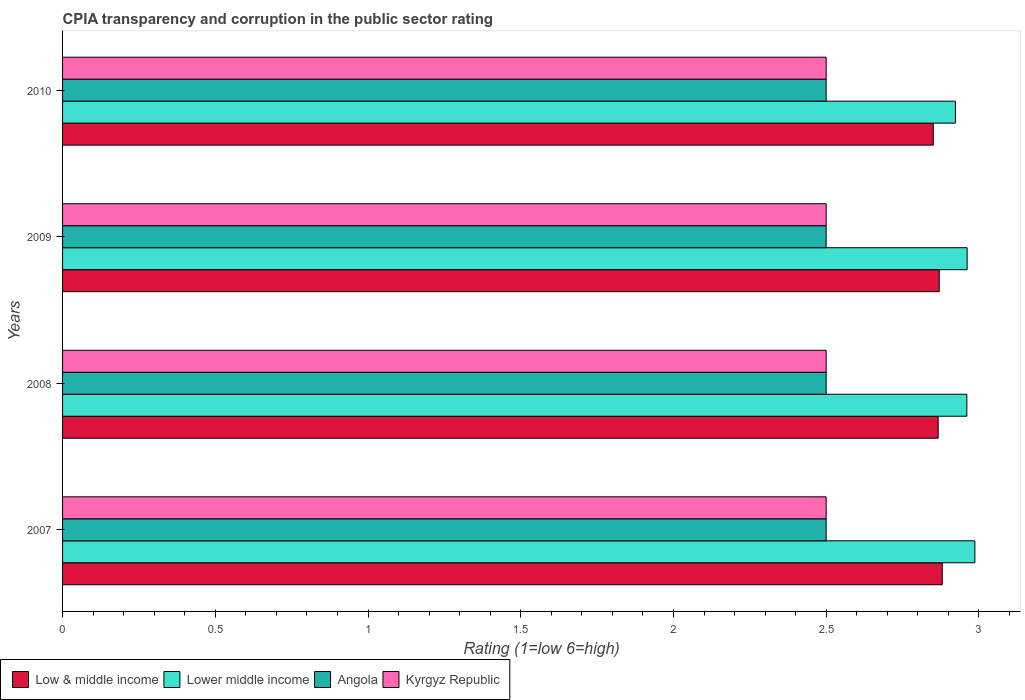Are the number of bars per tick equal to the number of legend labels?
Offer a very short reply. Yes. How many bars are there on the 4th tick from the top?
Your response must be concise. 4. How many bars are there on the 3rd tick from the bottom?
Ensure brevity in your answer.  4. What is the label of the 4th group of bars from the top?
Provide a short and direct response. 2007. In how many cases, is the number of bars for a given year not equal to the number of legend labels?
Provide a short and direct response. 0. What is the CPIA rating in Lower middle income in 2008?
Keep it short and to the point. 2.96. Across all years, what is the maximum CPIA rating in Low & middle income?
Give a very brief answer. 2.88. Across all years, what is the minimum CPIA rating in Lower middle income?
Your answer should be very brief. 2.92. In which year was the CPIA rating in Kyrgyz Republic maximum?
Your answer should be compact. 2007. What is the total CPIA rating in Lower middle income in the graph?
Keep it short and to the point. 11.83. What is the difference between the CPIA rating in Low & middle income in 2008 and that in 2010?
Provide a succinct answer. 0.02. What is the difference between the CPIA rating in Kyrgyz Republic in 2010 and the CPIA rating in Low & middle income in 2009?
Provide a succinct answer. -0.37. In the year 2009, what is the difference between the CPIA rating in Lower middle income and CPIA rating in Kyrgyz Republic?
Provide a succinct answer. 0.46. What is the ratio of the CPIA rating in Lower middle income in 2009 to that in 2010?
Your response must be concise. 1.01. Is the CPIA rating in Kyrgyz Republic in 2007 less than that in 2009?
Offer a very short reply. No. Is the difference between the CPIA rating in Lower middle income in 2008 and 2009 greater than the difference between the CPIA rating in Kyrgyz Republic in 2008 and 2009?
Make the answer very short. No. What is the difference between the highest and the second highest CPIA rating in Kyrgyz Republic?
Your response must be concise. 0. Is the sum of the CPIA rating in Kyrgyz Republic in 2009 and 2010 greater than the maximum CPIA rating in Lower middle income across all years?
Provide a short and direct response. Yes. Is it the case that in every year, the sum of the CPIA rating in Lower middle income and CPIA rating in Angola is greater than the sum of CPIA rating in Kyrgyz Republic and CPIA rating in Low & middle income?
Offer a terse response. Yes. What does the 1st bar from the top in 2007 represents?
Your answer should be compact. Kyrgyz Republic. What does the 4th bar from the bottom in 2010 represents?
Provide a succinct answer. Kyrgyz Republic. Is it the case that in every year, the sum of the CPIA rating in Angola and CPIA rating in Lower middle income is greater than the CPIA rating in Low & middle income?
Your answer should be compact. Yes. What is the difference between two consecutive major ticks on the X-axis?
Provide a short and direct response. 0.5. Does the graph contain any zero values?
Give a very brief answer. No. Where does the legend appear in the graph?
Your response must be concise. Bottom left. What is the title of the graph?
Offer a very short reply. CPIA transparency and corruption in the public sector rating. What is the label or title of the X-axis?
Provide a short and direct response. Rating (1=low 6=high). What is the label or title of the Y-axis?
Offer a very short reply. Years. What is the Rating (1=low 6=high) in Low & middle income in 2007?
Ensure brevity in your answer.  2.88. What is the Rating (1=low 6=high) of Lower middle income in 2007?
Provide a short and direct response. 2.99. What is the Rating (1=low 6=high) of Kyrgyz Republic in 2007?
Your answer should be very brief. 2.5. What is the Rating (1=low 6=high) in Low & middle income in 2008?
Your response must be concise. 2.87. What is the Rating (1=low 6=high) in Lower middle income in 2008?
Make the answer very short. 2.96. What is the Rating (1=low 6=high) of Angola in 2008?
Keep it short and to the point. 2.5. What is the Rating (1=low 6=high) of Low & middle income in 2009?
Provide a succinct answer. 2.87. What is the Rating (1=low 6=high) in Lower middle income in 2009?
Make the answer very short. 2.96. What is the Rating (1=low 6=high) of Kyrgyz Republic in 2009?
Ensure brevity in your answer.  2.5. What is the Rating (1=low 6=high) in Low & middle income in 2010?
Keep it short and to the point. 2.85. What is the Rating (1=low 6=high) in Lower middle income in 2010?
Offer a very short reply. 2.92. What is the Rating (1=low 6=high) of Angola in 2010?
Offer a very short reply. 2.5. What is the Rating (1=low 6=high) in Kyrgyz Republic in 2010?
Offer a very short reply. 2.5. Across all years, what is the maximum Rating (1=low 6=high) of Low & middle income?
Offer a terse response. 2.88. Across all years, what is the maximum Rating (1=low 6=high) of Lower middle income?
Keep it short and to the point. 2.99. Across all years, what is the minimum Rating (1=low 6=high) of Low & middle income?
Provide a short and direct response. 2.85. Across all years, what is the minimum Rating (1=low 6=high) in Lower middle income?
Provide a succinct answer. 2.92. Across all years, what is the minimum Rating (1=low 6=high) of Kyrgyz Republic?
Your response must be concise. 2.5. What is the total Rating (1=low 6=high) of Low & middle income in the graph?
Provide a short and direct response. 11.47. What is the total Rating (1=low 6=high) in Lower middle income in the graph?
Give a very brief answer. 11.83. What is the total Rating (1=low 6=high) of Kyrgyz Republic in the graph?
Your answer should be very brief. 10. What is the difference between the Rating (1=low 6=high) of Low & middle income in 2007 and that in 2008?
Offer a very short reply. 0.01. What is the difference between the Rating (1=low 6=high) of Lower middle income in 2007 and that in 2008?
Make the answer very short. 0.03. What is the difference between the Rating (1=low 6=high) in Low & middle income in 2007 and that in 2009?
Your answer should be compact. 0.01. What is the difference between the Rating (1=low 6=high) of Lower middle income in 2007 and that in 2009?
Ensure brevity in your answer.  0.03. What is the difference between the Rating (1=low 6=high) of Low & middle income in 2007 and that in 2010?
Offer a terse response. 0.03. What is the difference between the Rating (1=low 6=high) in Lower middle income in 2007 and that in 2010?
Keep it short and to the point. 0.06. What is the difference between the Rating (1=low 6=high) of Angola in 2007 and that in 2010?
Your answer should be compact. 0. What is the difference between the Rating (1=low 6=high) of Low & middle income in 2008 and that in 2009?
Ensure brevity in your answer.  -0. What is the difference between the Rating (1=low 6=high) of Lower middle income in 2008 and that in 2009?
Ensure brevity in your answer.  -0. What is the difference between the Rating (1=low 6=high) of Angola in 2008 and that in 2009?
Your answer should be very brief. 0. What is the difference between the Rating (1=low 6=high) in Low & middle income in 2008 and that in 2010?
Offer a terse response. 0.02. What is the difference between the Rating (1=low 6=high) of Lower middle income in 2008 and that in 2010?
Your answer should be compact. 0.04. What is the difference between the Rating (1=low 6=high) in Angola in 2008 and that in 2010?
Offer a very short reply. 0. What is the difference between the Rating (1=low 6=high) of Low & middle income in 2009 and that in 2010?
Your response must be concise. 0.02. What is the difference between the Rating (1=low 6=high) in Lower middle income in 2009 and that in 2010?
Ensure brevity in your answer.  0.04. What is the difference between the Rating (1=low 6=high) in Angola in 2009 and that in 2010?
Your answer should be very brief. 0. What is the difference between the Rating (1=low 6=high) in Kyrgyz Republic in 2009 and that in 2010?
Offer a very short reply. 0. What is the difference between the Rating (1=low 6=high) of Low & middle income in 2007 and the Rating (1=low 6=high) of Lower middle income in 2008?
Your answer should be compact. -0.08. What is the difference between the Rating (1=low 6=high) of Low & middle income in 2007 and the Rating (1=low 6=high) of Angola in 2008?
Provide a short and direct response. 0.38. What is the difference between the Rating (1=low 6=high) of Low & middle income in 2007 and the Rating (1=low 6=high) of Kyrgyz Republic in 2008?
Your answer should be compact. 0.38. What is the difference between the Rating (1=low 6=high) in Lower middle income in 2007 and the Rating (1=low 6=high) in Angola in 2008?
Your response must be concise. 0.49. What is the difference between the Rating (1=low 6=high) in Lower middle income in 2007 and the Rating (1=low 6=high) in Kyrgyz Republic in 2008?
Your answer should be compact. 0.49. What is the difference between the Rating (1=low 6=high) in Low & middle income in 2007 and the Rating (1=low 6=high) in Lower middle income in 2009?
Your answer should be compact. -0.08. What is the difference between the Rating (1=low 6=high) in Low & middle income in 2007 and the Rating (1=low 6=high) in Angola in 2009?
Offer a terse response. 0.38. What is the difference between the Rating (1=low 6=high) in Low & middle income in 2007 and the Rating (1=low 6=high) in Kyrgyz Republic in 2009?
Make the answer very short. 0.38. What is the difference between the Rating (1=low 6=high) in Lower middle income in 2007 and the Rating (1=low 6=high) in Angola in 2009?
Keep it short and to the point. 0.49. What is the difference between the Rating (1=low 6=high) of Lower middle income in 2007 and the Rating (1=low 6=high) of Kyrgyz Republic in 2009?
Offer a very short reply. 0.49. What is the difference between the Rating (1=low 6=high) of Low & middle income in 2007 and the Rating (1=low 6=high) of Lower middle income in 2010?
Offer a very short reply. -0.04. What is the difference between the Rating (1=low 6=high) in Low & middle income in 2007 and the Rating (1=low 6=high) in Angola in 2010?
Offer a terse response. 0.38. What is the difference between the Rating (1=low 6=high) in Low & middle income in 2007 and the Rating (1=low 6=high) in Kyrgyz Republic in 2010?
Keep it short and to the point. 0.38. What is the difference between the Rating (1=low 6=high) in Lower middle income in 2007 and the Rating (1=low 6=high) in Angola in 2010?
Provide a succinct answer. 0.49. What is the difference between the Rating (1=low 6=high) in Lower middle income in 2007 and the Rating (1=low 6=high) in Kyrgyz Republic in 2010?
Your response must be concise. 0.49. What is the difference between the Rating (1=low 6=high) of Low & middle income in 2008 and the Rating (1=low 6=high) of Lower middle income in 2009?
Make the answer very short. -0.09. What is the difference between the Rating (1=low 6=high) in Low & middle income in 2008 and the Rating (1=low 6=high) in Angola in 2009?
Ensure brevity in your answer.  0.37. What is the difference between the Rating (1=low 6=high) of Low & middle income in 2008 and the Rating (1=low 6=high) of Kyrgyz Republic in 2009?
Give a very brief answer. 0.37. What is the difference between the Rating (1=low 6=high) in Lower middle income in 2008 and the Rating (1=low 6=high) in Angola in 2009?
Your answer should be compact. 0.46. What is the difference between the Rating (1=low 6=high) of Lower middle income in 2008 and the Rating (1=low 6=high) of Kyrgyz Republic in 2009?
Offer a very short reply. 0.46. What is the difference between the Rating (1=low 6=high) of Angola in 2008 and the Rating (1=low 6=high) of Kyrgyz Republic in 2009?
Ensure brevity in your answer.  0. What is the difference between the Rating (1=low 6=high) of Low & middle income in 2008 and the Rating (1=low 6=high) of Lower middle income in 2010?
Your answer should be very brief. -0.06. What is the difference between the Rating (1=low 6=high) of Low & middle income in 2008 and the Rating (1=low 6=high) of Angola in 2010?
Your answer should be very brief. 0.37. What is the difference between the Rating (1=low 6=high) in Low & middle income in 2008 and the Rating (1=low 6=high) in Kyrgyz Republic in 2010?
Offer a terse response. 0.37. What is the difference between the Rating (1=low 6=high) of Lower middle income in 2008 and the Rating (1=low 6=high) of Angola in 2010?
Ensure brevity in your answer.  0.46. What is the difference between the Rating (1=low 6=high) of Lower middle income in 2008 and the Rating (1=low 6=high) of Kyrgyz Republic in 2010?
Offer a terse response. 0.46. What is the difference between the Rating (1=low 6=high) of Angola in 2008 and the Rating (1=low 6=high) of Kyrgyz Republic in 2010?
Make the answer very short. 0. What is the difference between the Rating (1=low 6=high) of Low & middle income in 2009 and the Rating (1=low 6=high) of Lower middle income in 2010?
Your answer should be compact. -0.05. What is the difference between the Rating (1=low 6=high) in Low & middle income in 2009 and the Rating (1=low 6=high) in Angola in 2010?
Make the answer very short. 0.37. What is the difference between the Rating (1=low 6=high) of Low & middle income in 2009 and the Rating (1=low 6=high) of Kyrgyz Republic in 2010?
Your response must be concise. 0.37. What is the difference between the Rating (1=low 6=high) in Lower middle income in 2009 and the Rating (1=low 6=high) in Angola in 2010?
Make the answer very short. 0.46. What is the difference between the Rating (1=low 6=high) of Lower middle income in 2009 and the Rating (1=low 6=high) of Kyrgyz Republic in 2010?
Provide a short and direct response. 0.46. What is the average Rating (1=low 6=high) of Low & middle income per year?
Offer a very short reply. 2.87. What is the average Rating (1=low 6=high) of Lower middle income per year?
Your answer should be compact. 2.96. In the year 2007, what is the difference between the Rating (1=low 6=high) in Low & middle income and Rating (1=low 6=high) in Lower middle income?
Offer a terse response. -0.11. In the year 2007, what is the difference between the Rating (1=low 6=high) in Low & middle income and Rating (1=low 6=high) in Angola?
Keep it short and to the point. 0.38. In the year 2007, what is the difference between the Rating (1=low 6=high) of Low & middle income and Rating (1=low 6=high) of Kyrgyz Republic?
Your answer should be very brief. 0.38. In the year 2007, what is the difference between the Rating (1=low 6=high) in Lower middle income and Rating (1=low 6=high) in Angola?
Make the answer very short. 0.49. In the year 2007, what is the difference between the Rating (1=low 6=high) in Lower middle income and Rating (1=low 6=high) in Kyrgyz Republic?
Make the answer very short. 0.49. In the year 2007, what is the difference between the Rating (1=low 6=high) of Angola and Rating (1=low 6=high) of Kyrgyz Republic?
Offer a very short reply. 0. In the year 2008, what is the difference between the Rating (1=low 6=high) of Low & middle income and Rating (1=low 6=high) of Lower middle income?
Keep it short and to the point. -0.09. In the year 2008, what is the difference between the Rating (1=low 6=high) in Low & middle income and Rating (1=low 6=high) in Angola?
Your answer should be very brief. 0.37. In the year 2008, what is the difference between the Rating (1=low 6=high) of Low & middle income and Rating (1=low 6=high) of Kyrgyz Republic?
Give a very brief answer. 0.37. In the year 2008, what is the difference between the Rating (1=low 6=high) in Lower middle income and Rating (1=low 6=high) in Angola?
Provide a succinct answer. 0.46. In the year 2008, what is the difference between the Rating (1=low 6=high) in Lower middle income and Rating (1=low 6=high) in Kyrgyz Republic?
Offer a very short reply. 0.46. In the year 2009, what is the difference between the Rating (1=low 6=high) in Low & middle income and Rating (1=low 6=high) in Lower middle income?
Offer a terse response. -0.09. In the year 2009, what is the difference between the Rating (1=low 6=high) in Low & middle income and Rating (1=low 6=high) in Angola?
Provide a succinct answer. 0.37. In the year 2009, what is the difference between the Rating (1=low 6=high) in Low & middle income and Rating (1=low 6=high) in Kyrgyz Republic?
Your response must be concise. 0.37. In the year 2009, what is the difference between the Rating (1=low 6=high) of Lower middle income and Rating (1=low 6=high) of Angola?
Give a very brief answer. 0.46. In the year 2009, what is the difference between the Rating (1=low 6=high) in Lower middle income and Rating (1=low 6=high) in Kyrgyz Republic?
Offer a very short reply. 0.46. In the year 2010, what is the difference between the Rating (1=low 6=high) in Low & middle income and Rating (1=low 6=high) in Lower middle income?
Provide a short and direct response. -0.07. In the year 2010, what is the difference between the Rating (1=low 6=high) in Low & middle income and Rating (1=low 6=high) in Angola?
Ensure brevity in your answer.  0.35. In the year 2010, what is the difference between the Rating (1=low 6=high) of Low & middle income and Rating (1=low 6=high) of Kyrgyz Republic?
Make the answer very short. 0.35. In the year 2010, what is the difference between the Rating (1=low 6=high) in Lower middle income and Rating (1=low 6=high) in Angola?
Give a very brief answer. 0.42. In the year 2010, what is the difference between the Rating (1=low 6=high) in Lower middle income and Rating (1=low 6=high) in Kyrgyz Republic?
Give a very brief answer. 0.42. What is the ratio of the Rating (1=low 6=high) of Low & middle income in 2007 to that in 2008?
Give a very brief answer. 1. What is the ratio of the Rating (1=low 6=high) in Lower middle income in 2007 to that in 2008?
Your answer should be compact. 1.01. What is the ratio of the Rating (1=low 6=high) of Angola in 2007 to that in 2008?
Ensure brevity in your answer.  1. What is the ratio of the Rating (1=low 6=high) in Kyrgyz Republic in 2007 to that in 2008?
Provide a succinct answer. 1. What is the ratio of the Rating (1=low 6=high) of Lower middle income in 2007 to that in 2009?
Your response must be concise. 1.01. What is the ratio of the Rating (1=low 6=high) in Kyrgyz Republic in 2007 to that in 2009?
Your answer should be very brief. 1. What is the ratio of the Rating (1=low 6=high) of Low & middle income in 2007 to that in 2010?
Offer a very short reply. 1.01. What is the ratio of the Rating (1=low 6=high) of Lower middle income in 2007 to that in 2010?
Ensure brevity in your answer.  1.02. What is the ratio of the Rating (1=low 6=high) of Angola in 2007 to that in 2010?
Give a very brief answer. 1. What is the ratio of the Rating (1=low 6=high) of Low & middle income in 2008 to that in 2009?
Keep it short and to the point. 1. What is the ratio of the Rating (1=low 6=high) in Lower middle income in 2008 to that in 2009?
Keep it short and to the point. 1. What is the ratio of the Rating (1=low 6=high) of Low & middle income in 2008 to that in 2010?
Your answer should be compact. 1.01. What is the ratio of the Rating (1=low 6=high) in Lower middle income in 2008 to that in 2010?
Give a very brief answer. 1.01. What is the ratio of the Rating (1=low 6=high) in Angola in 2008 to that in 2010?
Make the answer very short. 1. What is the ratio of the Rating (1=low 6=high) of Low & middle income in 2009 to that in 2010?
Keep it short and to the point. 1.01. What is the ratio of the Rating (1=low 6=high) in Lower middle income in 2009 to that in 2010?
Offer a terse response. 1.01. What is the ratio of the Rating (1=low 6=high) of Angola in 2009 to that in 2010?
Offer a very short reply. 1. What is the difference between the highest and the second highest Rating (1=low 6=high) in Low & middle income?
Ensure brevity in your answer.  0.01. What is the difference between the highest and the second highest Rating (1=low 6=high) of Lower middle income?
Keep it short and to the point. 0.03. What is the difference between the highest and the second highest Rating (1=low 6=high) in Angola?
Provide a short and direct response. 0. What is the difference between the highest and the lowest Rating (1=low 6=high) in Low & middle income?
Keep it short and to the point. 0.03. What is the difference between the highest and the lowest Rating (1=low 6=high) in Lower middle income?
Your response must be concise. 0.06. What is the difference between the highest and the lowest Rating (1=low 6=high) in Kyrgyz Republic?
Your answer should be compact. 0. 